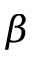<formula> <loc_0><loc_0><loc_500><loc_500>\beta</formula> 